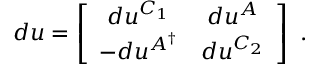<formula> <loc_0><loc_0><loc_500><loc_500>d u = \left [ \begin{array} { c c } { { d u ^ { C _ { 1 } } } } & { { d u ^ { A } } } \\ { { - d u ^ { A ^ { \dagger } } } } & { { d u ^ { C _ { 2 } } } } \end{array} \right ] \ .</formula> 